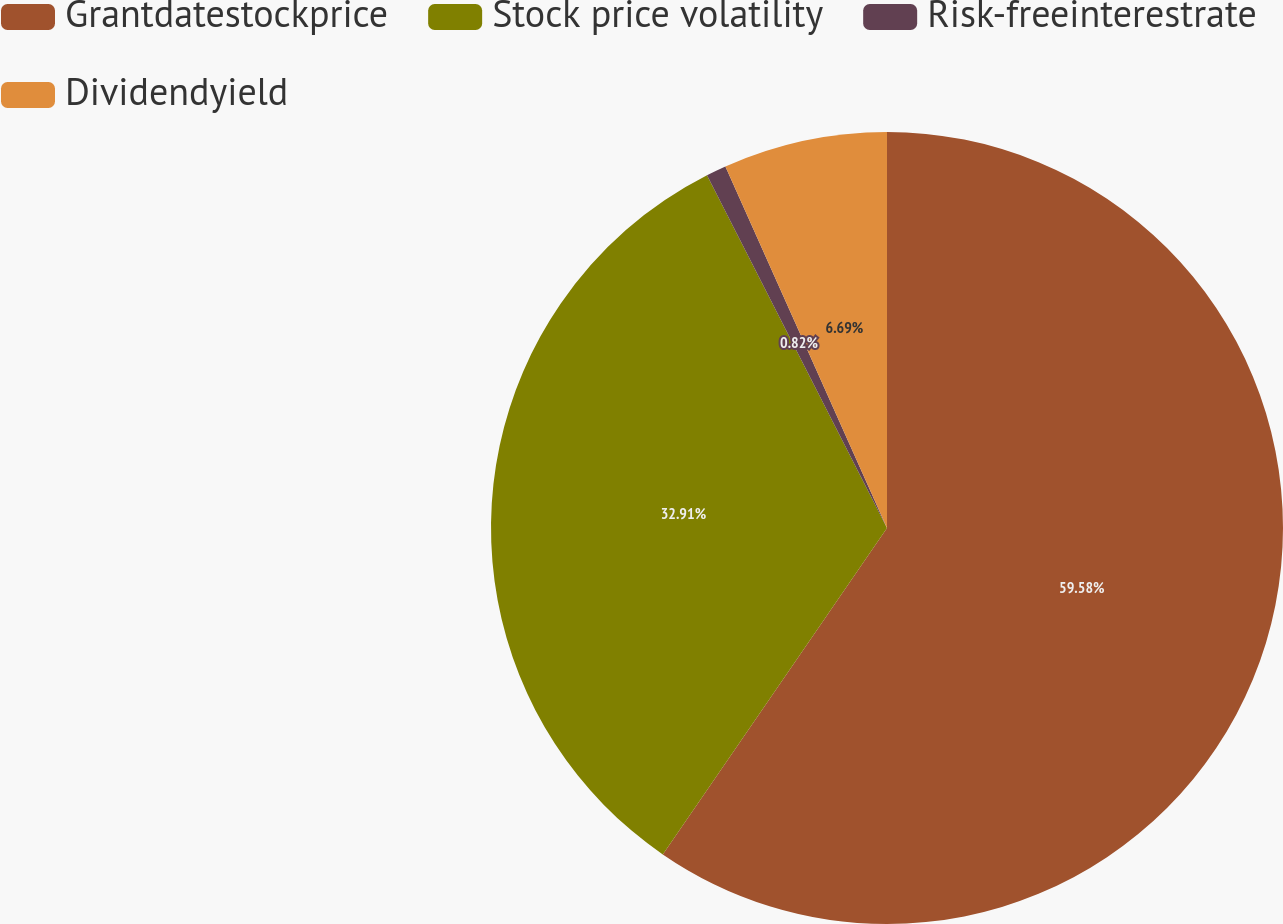Convert chart to OTSL. <chart><loc_0><loc_0><loc_500><loc_500><pie_chart><fcel>Grantdatestockprice<fcel>Stock price volatility<fcel>Risk-freeinterestrate<fcel>Dividendyield<nl><fcel>59.58%<fcel>32.91%<fcel>0.82%<fcel>6.69%<nl></chart> 